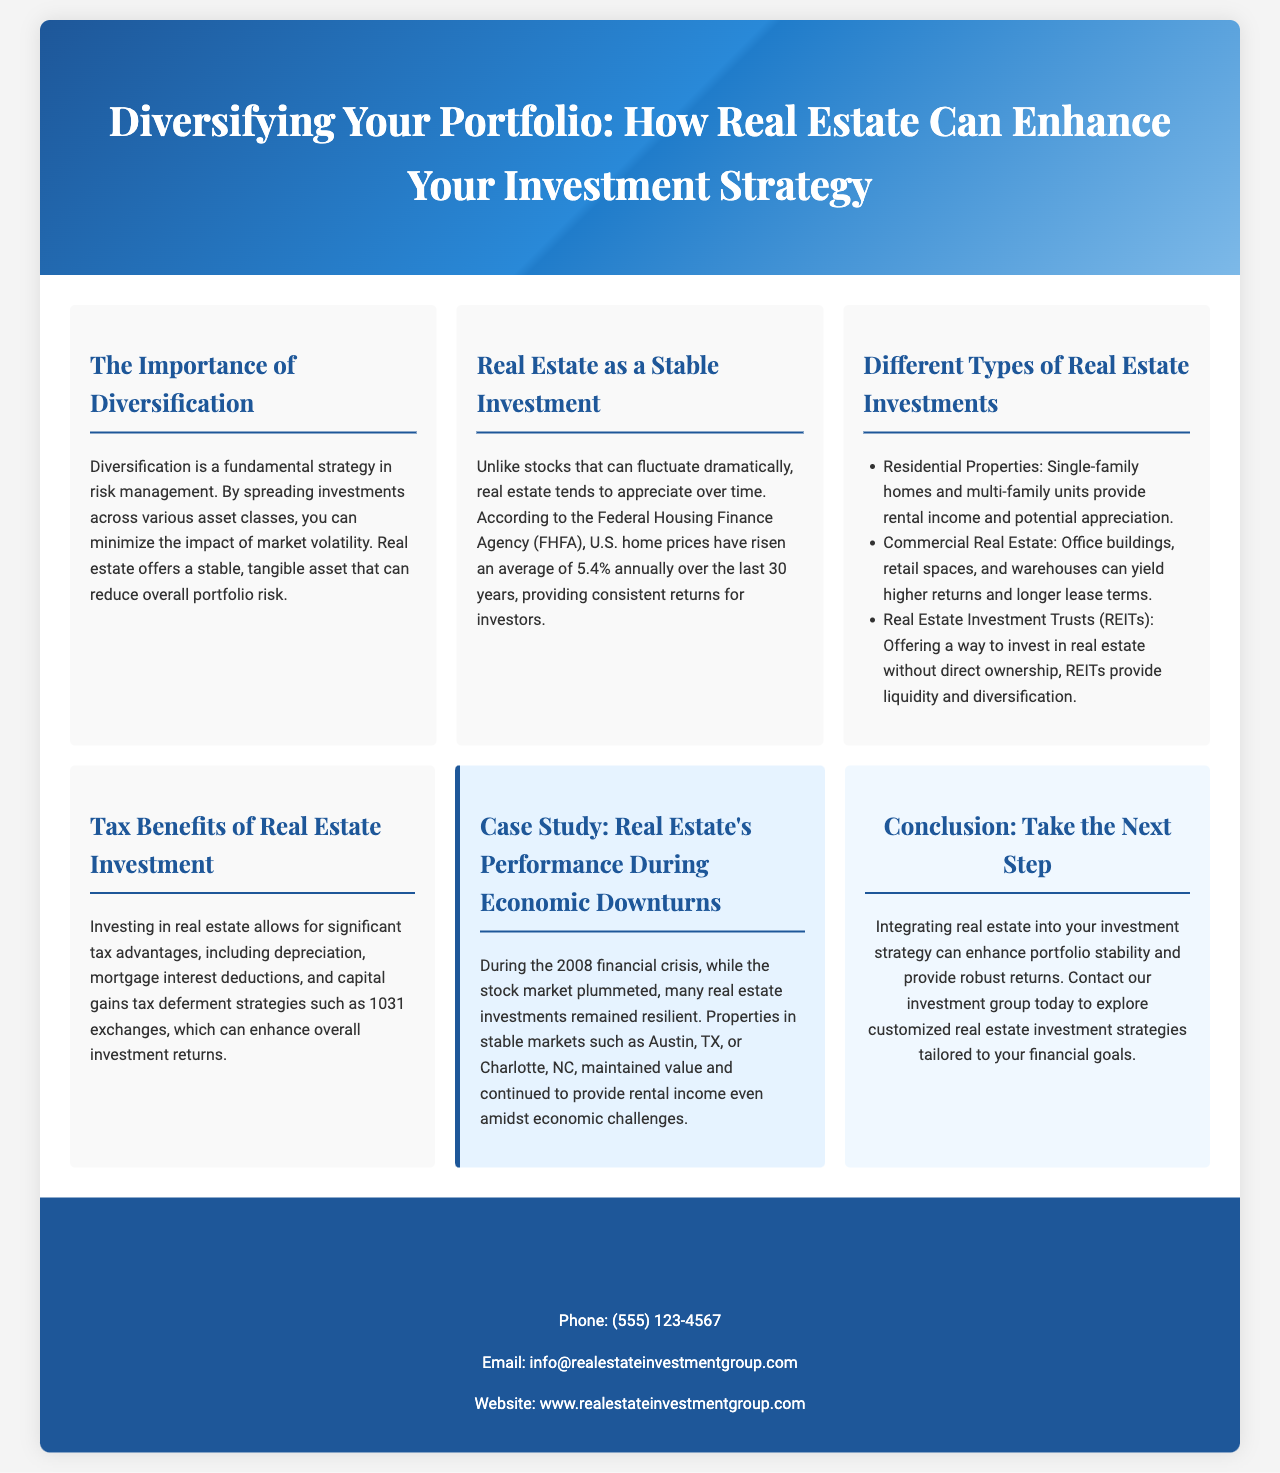What is the average annual rise in U.S. home prices? The document states that U.S. home prices have risen an average of 5.4% annually over the last 30 years.
Answer: 5.4% What types of properties are mentioned under residential investments? The brochure mentions single-family homes and multi-family units as categories of residential properties.
Answer: Single-family homes and multi-family units What is a key benefit mentioned about investing in real estate? The document highlights tax advantages such as depreciation and mortgage interest deductions.
Answer: Tax advantages During which financial crisis did real estate investments perform well? The case study in the brochure references the 2008 financial crisis.
Answer: 2008 What do REITs stand for? The document describes REITs as Real Estate Investment Trusts.
Answer: Real Estate Investment Trusts What is one example of a stable real estate market mentioned? The case study cites Austin, TX, as an example of a stable market.
Answer: Austin, TX How can real estate enhance overall investment returns? The document talks about strategies such as capital gains tax deferment through 1031 exchanges to enhance returns.
Answer: 1031 exchanges What is the contact phone number for the Real Estate Investment Group? The contact information lists the phone number as (555) 123-4567.
Answer: (555) 123-4567 